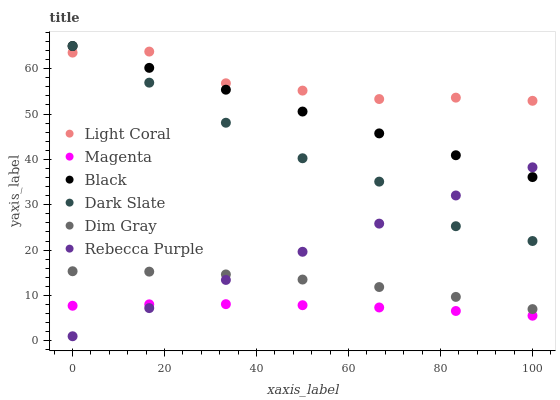Does Magenta have the minimum area under the curve?
Answer yes or no. Yes. Does Light Coral have the maximum area under the curve?
Answer yes or no. Yes. Does Dark Slate have the minimum area under the curve?
Answer yes or no. No. Does Dark Slate have the maximum area under the curve?
Answer yes or no. No. Is Rebecca Purple the smoothest?
Answer yes or no. Yes. Is Light Coral the roughest?
Answer yes or no. Yes. Is Dark Slate the smoothest?
Answer yes or no. No. Is Dark Slate the roughest?
Answer yes or no. No. Does Rebecca Purple have the lowest value?
Answer yes or no. Yes. Does Dark Slate have the lowest value?
Answer yes or no. No. Does Black have the highest value?
Answer yes or no. Yes. Does Light Coral have the highest value?
Answer yes or no. No. Is Magenta less than Dim Gray?
Answer yes or no. Yes. Is Black greater than Dim Gray?
Answer yes or no. Yes. Does Rebecca Purple intersect Dim Gray?
Answer yes or no. Yes. Is Rebecca Purple less than Dim Gray?
Answer yes or no. No. Is Rebecca Purple greater than Dim Gray?
Answer yes or no. No. Does Magenta intersect Dim Gray?
Answer yes or no. No. 